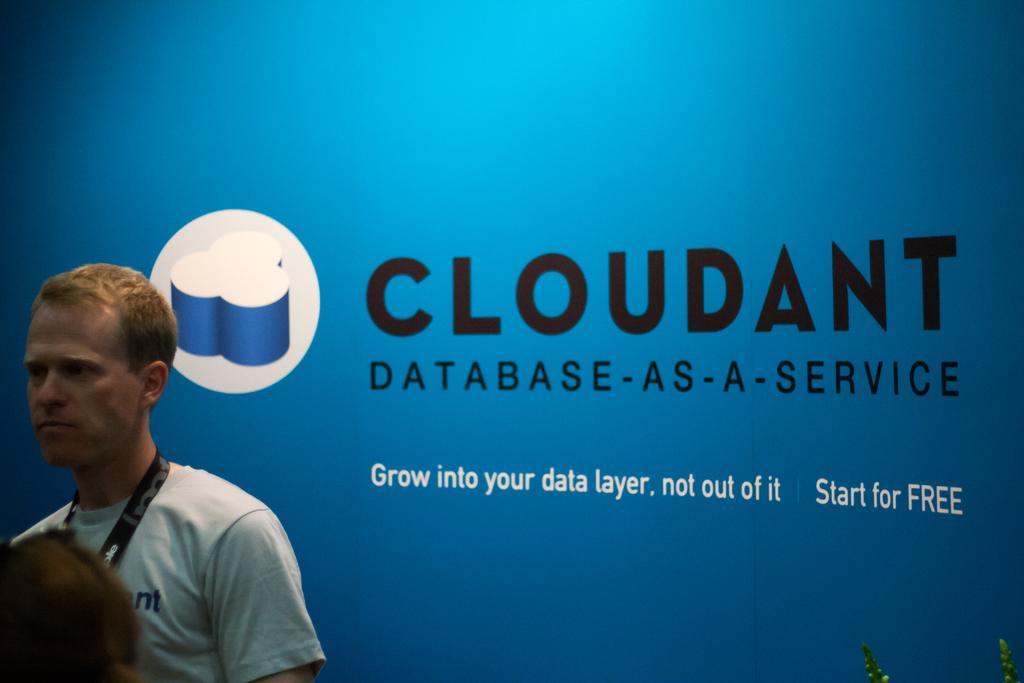Please provide a concise description of this image. On the left side there is a person wearing a tag. In the back there is a blue wall with something written on that. Also there is a logo. 